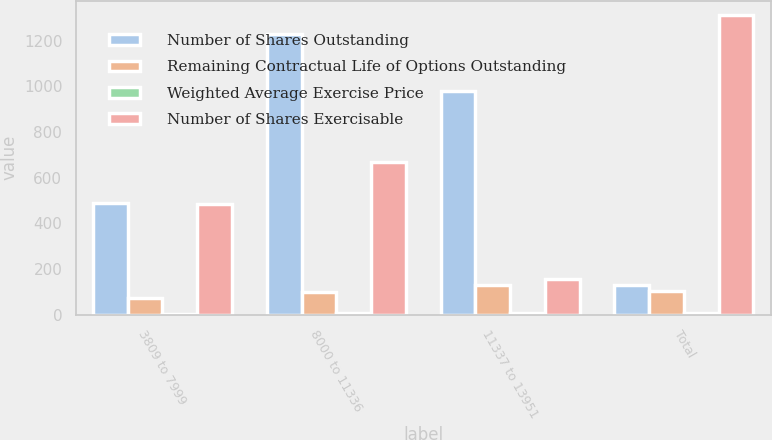<chart> <loc_0><loc_0><loc_500><loc_500><stacked_bar_chart><ecel><fcel>3809 to 7999<fcel>8000 to 11336<fcel>11337 to 13951<fcel>Total<nl><fcel>Number of Shares Outstanding<fcel>490<fcel>1228<fcel>979<fcel>130.09<nl><fcel>Remaining Contractual Life of Options Outstanding<fcel>74.22<fcel>100.68<fcel>130.09<fcel>106.55<nl><fcel>Weighted Average Exercise Price<fcel>4.1<fcel>7<fcel>9.3<fcel>7.3<nl><fcel>Number of Shares Exercisable<fcel>483<fcel>670<fcel>157<fcel>1310<nl></chart> 